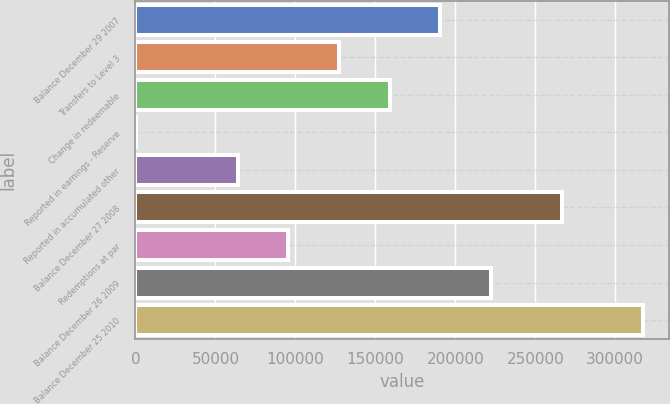Convert chart. <chart><loc_0><loc_0><loc_500><loc_500><bar_chart><fcel>Balance December 29 2007<fcel>Transfers to Level 3<fcel>Change in redeemable<fcel>Reported in earnings - Reserve<fcel>Reported in accumulated other<fcel>Balance December 27 2008<fcel>Redemptions at par<fcel>Balance December 26 2009<fcel>Balance December 25 2010<nl><fcel>190704<fcel>127303<fcel>159004<fcel>500<fcel>63901.4<fcel>266581<fcel>95602.1<fcel>222405<fcel>317507<nl></chart> 